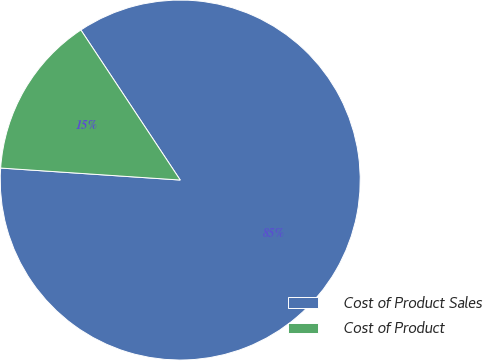Convert chart to OTSL. <chart><loc_0><loc_0><loc_500><loc_500><pie_chart><fcel>Cost of Product Sales<fcel>Cost of Product<nl><fcel>85.37%<fcel>14.63%<nl></chart> 